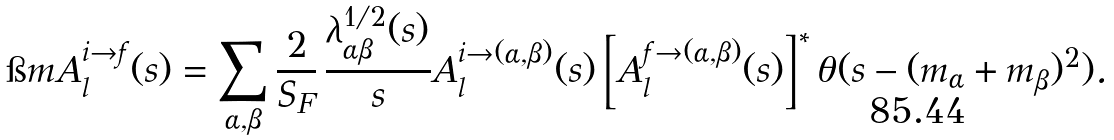<formula> <loc_0><loc_0><loc_500><loc_500>\i m A _ { l } ^ { i \rightarrow f } ( s ) = \sum _ { \alpha , \beta } \frac { 2 } { S _ { F } } \, \frac { \lambda ^ { 1 / 2 } _ { \alpha \beta } ( s ) } { s } A _ { l } ^ { i \rightarrow ( \alpha , \beta ) } ( s ) \left [ A _ { l } ^ { f \rightarrow ( \alpha , \beta ) } ( s ) \right ] ^ { * } \theta ( s - ( m _ { \alpha } + m _ { \beta } ) ^ { 2 } ) .</formula> 